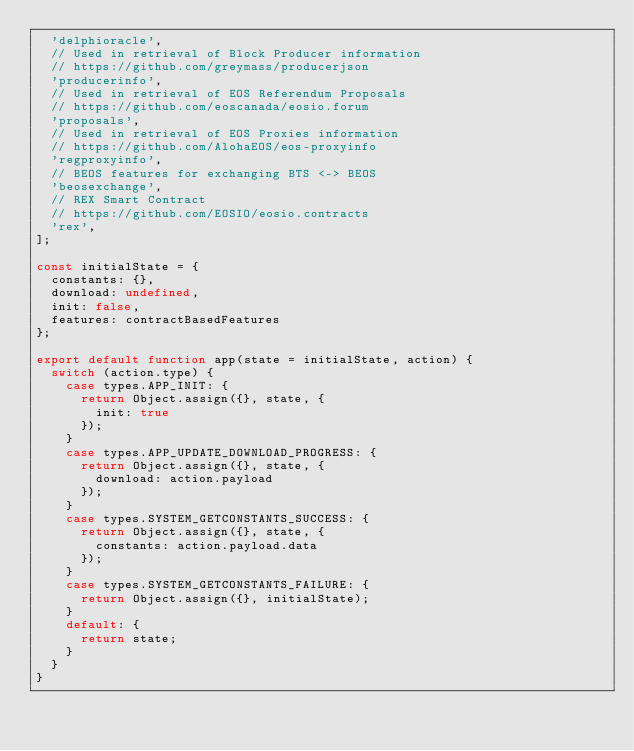<code> <loc_0><loc_0><loc_500><loc_500><_JavaScript_>  'delphioracle',
  // Used in retrieval of Block Producer information
  // https://github.com/greymass/producerjson
  'producerinfo',
  // Used in retrieval of EOS Referendum Proposals
  // https://github.com/eoscanada/eosio.forum
  'proposals',
  // Used in retrieval of EOS Proxies information
  // https://github.com/AlohaEOS/eos-proxyinfo
  'regproxyinfo',
  // BEOS features for exchanging BTS <-> BEOS
  'beosexchange',
  // REX Smart Contract
  // https://github.com/EOSIO/eosio.contracts
  'rex',
];

const initialState = {
  constants: {},
  download: undefined,
  init: false,
  features: contractBasedFeatures
};

export default function app(state = initialState, action) {
  switch (action.type) {
    case types.APP_INIT: {
      return Object.assign({}, state, {
        init: true
      });
    }
    case types.APP_UPDATE_DOWNLOAD_PROGRESS: {
      return Object.assign({}, state, {
        download: action.payload
      });
    }
    case types.SYSTEM_GETCONSTANTS_SUCCESS: {
      return Object.assign({}, state, {
        constants: action.payload.data
      });
    }
    case types.SYSTEM_GETCONSTANTS_FAILURE: {
      return Object.assign({}, initialState);
    }
    default: {
      return state;
    }
  }
}
</code> 